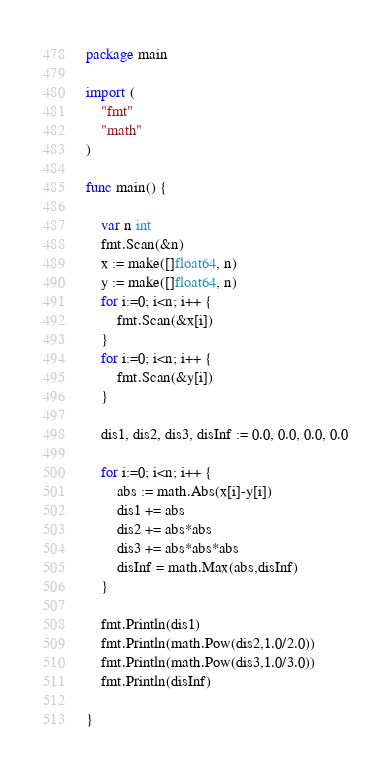<code> <loc_0><loc_0><loc_500><loc_500><_Go_>package main

import (
	"fmt"
	"math"
)

func main() {

	var n int
	fmt.Scan(&n)
	x := make([]float64, n)
	y := make([]float64, n)
	for i:=0; i<n; i++ {
		fmt.Scan(&x[i])
	}
	for i:=0; i<n; i++ {
		fmt.Scan(&y[i])
	}

	dis1, dis2, dis3, disInf := 0.0, 0.0, 0.0, 0.0

	for i:=0; i<n; i++ {
		abs := math.Abs(x[i]-y[i])
		dis1 += abs
		dis2 += abs*abs
		dis3 += abs*abs*abs
		disInf = math.Max(abs,disInf)
	}

	fmt.Println(dis1)
	fmt.Println(math.Pow(dis2,1.0/2.0))
	fmt.Println(math.Pow(dis3,1.0/3.0))
	fmt.Println(disInf)

}
</code> 